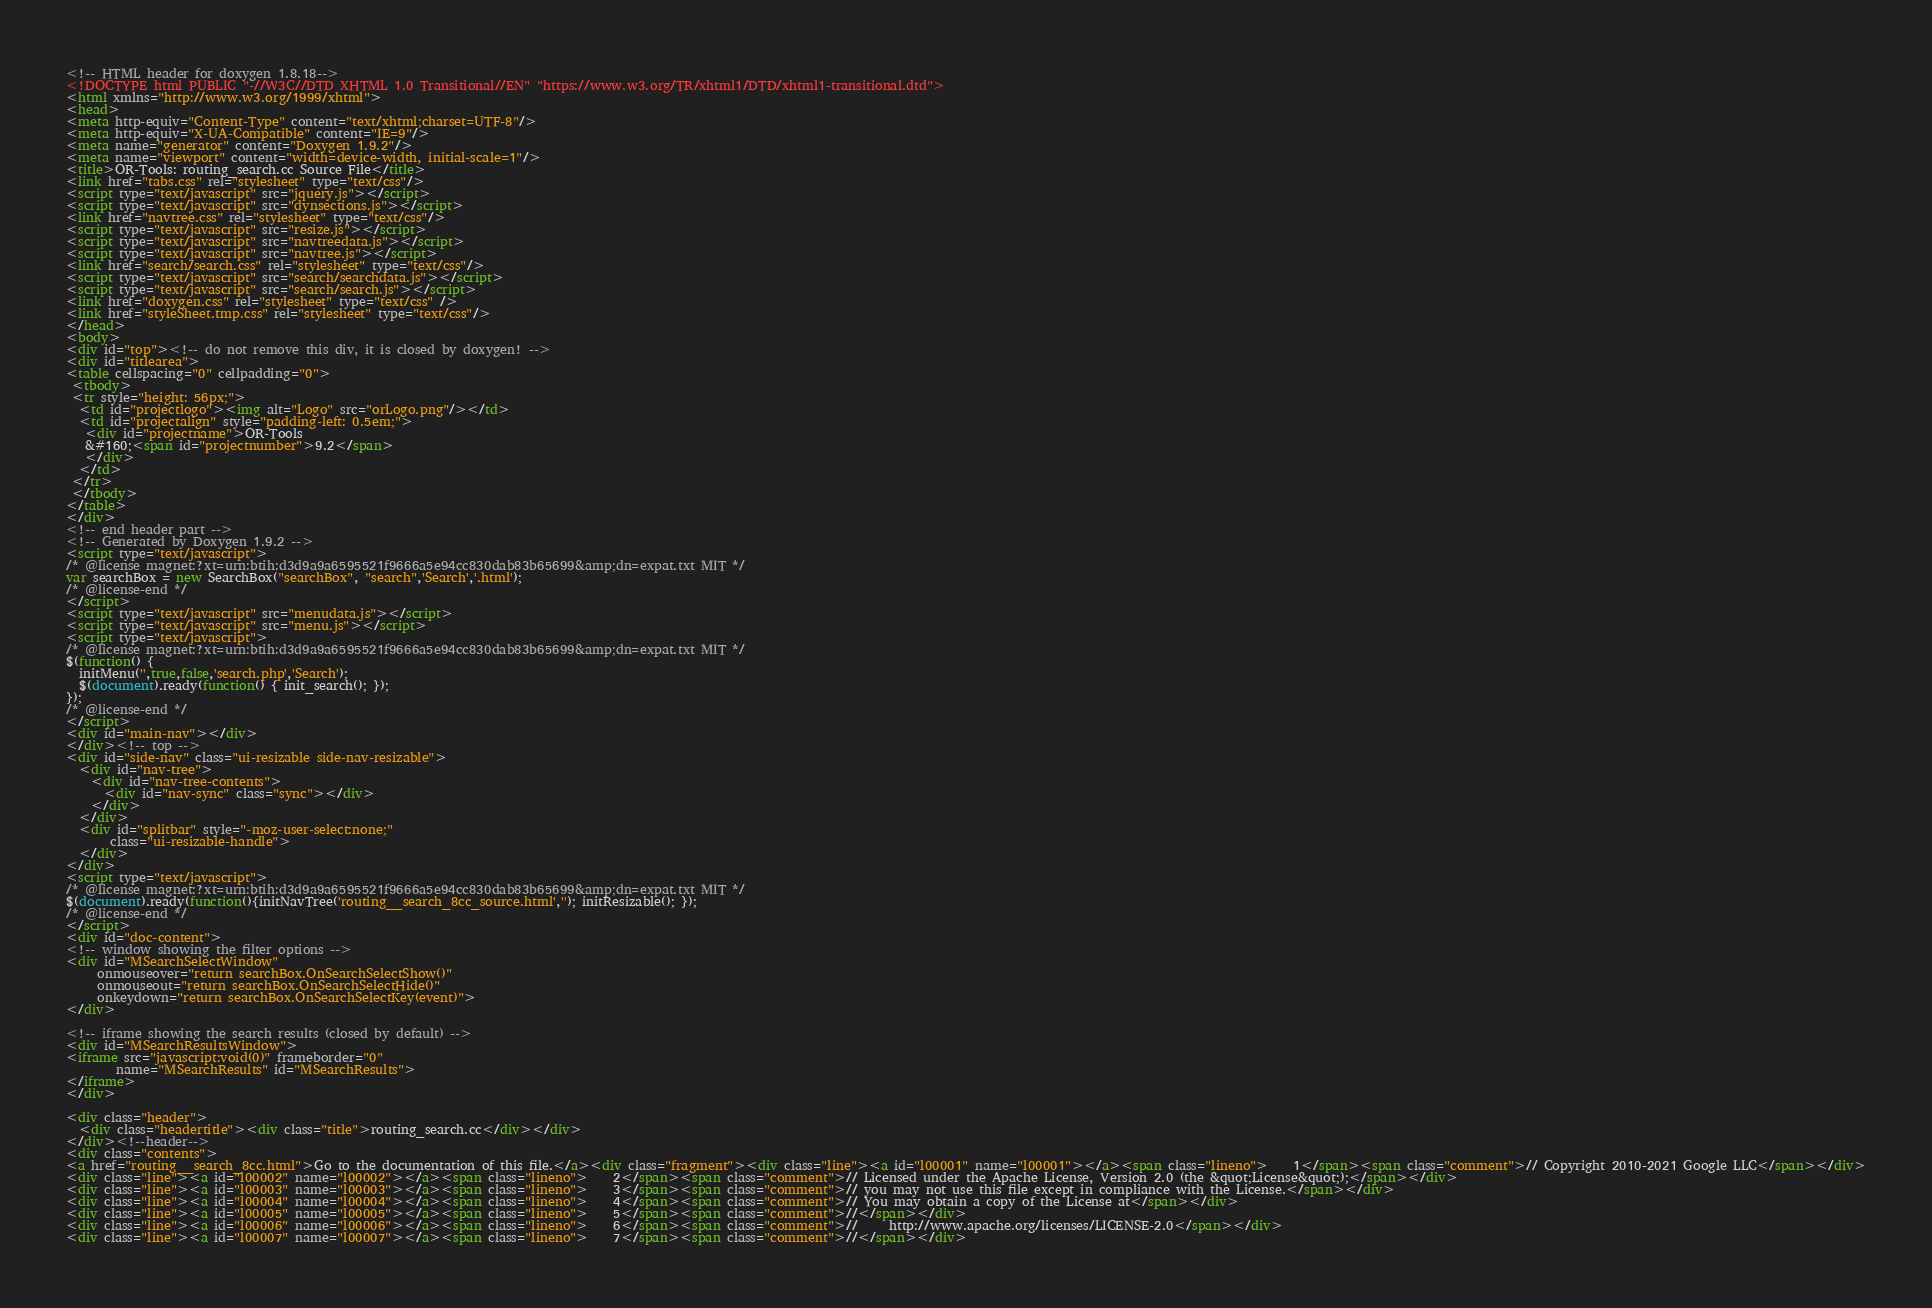<code> <loc_0><loc_0><loc_500><loc_500><_HTML_><!-- HTML header for doxygen 1.8.18-->
<!DOCTYPE html PUBLIC "-//W3C//DTD XHTML 1.0 Transitional//EN" "https://www.w3.org/TR/xhtml1/DTD/xhtml1-transitional.dtd">
<html xmlns="http://www.w3.org/1999/xhtml">
<head>
<meta http-equiv="Content-Type" content="text/xhtml;charset=UTF-8"/>
<meta http-equiv="X-UA-Compatible" content="IE=9"/>
<meta name="generator" content="Doxygen 1.9.2"/>
<meta name="viewport" content="width=device-width, initial-scale=1"/>
<title>OR-Tools: routing_search.cc Source File</title>
<link href="tabs.css" rel="stylesheet" type="text/css"/>
<script type="text/javascript" src="jquery.js"></script>
<script type="text/javascript" src="dynsections.js"></script>
<link href="navtree.css" rel="stylesheet" type="text/css"/>
<script type="text/javascript" src="resize.js"></script>
<script type="text/javascript" src="navtreedata.js"></script>
<script type="text/javascript" src="navtree.js"></script>
<link href="search/search.css" rel="stylesheet" type="text/css"/>
<script type="text/javascript" src="search/searchdata.js"></script>
<script type="text/javascript" src="search/search.js"></script>
<link href="doxygen.css" rel="stylesheet" type="text/css" />
<link href="styleSheet.tmp.css" rel="stylesheet" type="text/css"/>
</head>
<body>
<div id="top"><!-- do not remove this div, it is closed by doxygen! -->
<div id="titlearea">
<table cellspacing="0" cellpadding="0">
 <tbody>
 <tr style="height: 56px;">
  <td id="projectlogo"><img alt="Logo" src="orLogo.png"/></td>
  <td id="projectalign" style="padding-left: 0.5em;">
   <div id="projectname">OR-Tools
   &#160;<span id="projectnumber">9.2</span>
   </div>
  </td>
 </tr>
 </tbody>
</table>
</div>
<!-- end header part -->
<!-- Generated by Doxygen 1.9.2 -->
<script type="text/javascript">
/* @license magnet:?xt=urn:btih:d3d9a9a6595521f9666a5e94cc830dab83b65699&amp;dn=expat.txt MIT */
var searchBox = new SearchBox("searchBox", "search",'Search','.html');
/* @license-end */
</script>
<script type="text/javascript" src="menudata.js"></script>
<script type="text/javascript" src="menu.js"></script>
<script type="text/javascript">
/* @license magnet:?xt=urn:btih:d3d9a9a6595521f9666a5e94cc830dab83b65699&amp;dn=expat.txt MIT */
$(function() {
  initMenu('',true,false,'search.php','Search');
  $(document).ready(function() { init_search(); });
});
/* @license-end */
</script>
<div id="main-nav"></div>
</div><!-- top -->
<div id="side-nav" class="ui-resizable side-nav-resizable">
  <div id="nav-tree">
    <div id="nav-tree-contents">
      <div id="nav-sync" class="sync"></div>
    </div>
  </div>
  <div id="splitbar" style="-moz-user-select:none;" 
       class="ui-resizable-handle">
  </div>
</div>
<script type="text/javascript">
/* @license magnet:?xt=urn:btih:d3d9a9a6595521f9666a5e94cc830dab83b65699&amp;dn=expat.txt MIT */
$(document).ready(function(){initNavTree('routing__search_8cc_source.html',''); initResizable(); });
/* @license-end */
</script>
<div id="doc-content">
<!-- window showing the filter options -->
<div id="MSearchSelectWindow"
     onmouseover="return searchBox.OnSearchSelectShow()"
     onmouseout="return searchBox.OnSearchSelectHide()"
     onkeydown="return searchBox.OnSearchSelectKey(event)">
</div>

<!-- iframe showing the search results (closed by default) -->
<div id="MSearchResultsWindow">
<iframe src="javascript:void(0)" frameborder="0" 
        name="MSearchResults" id="MSearchResults">
</iframe>
</div>

<div class="header">
  <div class="headertitle"><div class="title">routing_search.cc</div></div>
</div><!--header-->
<div class="contents">
<a href="routing__search_8cc.html">Go to the documentation of this file.</a><div class="fragment"><div class="line"><a id="l00001" name="l00001"></a><span class="lineno">    1</span><span class="comment">// Copyright 2010-2021 Google LLC</span></div>
<div class="line"><a id="l00002" name="l00002"></a><span class="lineno">    2</span><span class="comment">// Licensed under the Apache License, Version 2.0 (the &quot;License&quot;);</span></div>
<div class="line"><a id="l00003" name="l00003"></a><span class="lineno">    3</span><span class="comment">// you may not use this file except in compliance with the License.</span></div>
<div class="line"><a id="l00004" name="l00004"></a><span class="lineno">    4</span><span class="comment">// You may obtain a copy of the License at</span></div>
<div class="line"><a id="l00005" name="l00005"></a><span class="lineno">    5</span><span class="comment">//</span></div>
<div class="line"><a id="l00006" name="l00006"></a><span class="lineno">    6</span><span class="comment">//     http://www.apache.org/licenses/LICENSE-2.0</span></div>
<div class="line"><a id="l00007" name="l00007"></a><span class="lineno">    7</span><span class="comment">//</span></div></code> 